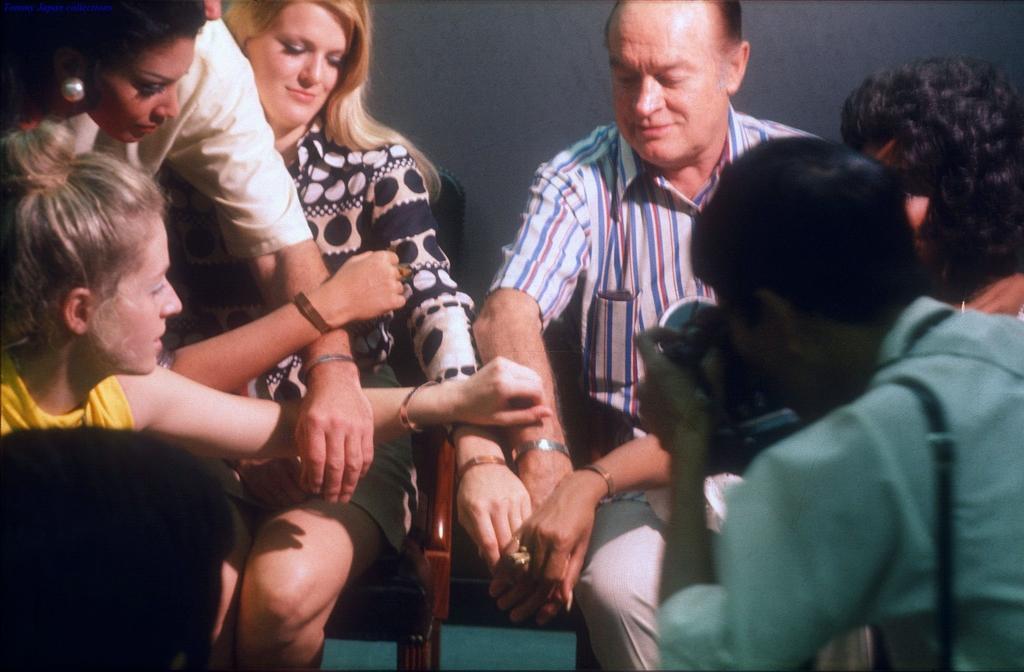Can you describe this image briefly? The picture consists of a group of people, few are sitting in chairs. In the background there is wall. 